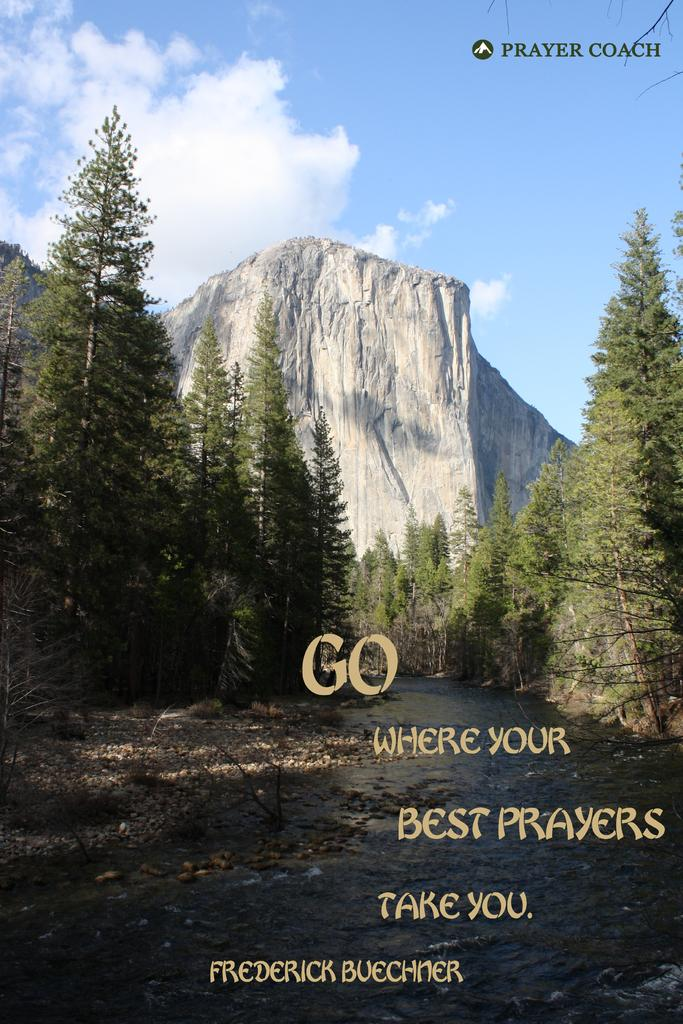What is the main feature of the image? The main feature of the image is a water surface. What can be seen on both sides of the water surface? There are trees on either side of the water surface. What is visible in the background of the image? There is a mountain and the sky visible in the background of the image. How many clocks can be seen hanging from the trees in the image? There are no clocks visible in the image; it features a water surface, trees, a mountain, and the sky. Is there a girl sitting on the mountain in the image? There is no girl present in the image; it only features a water surface, trees, a mountain, and the sky. 